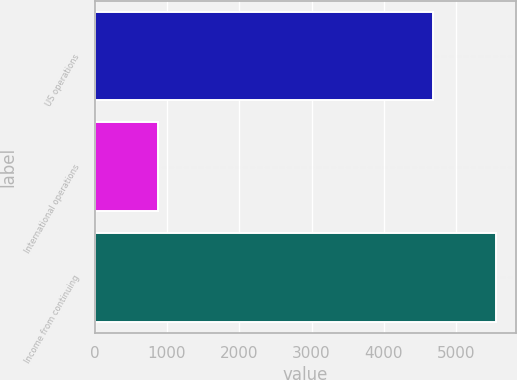Convert chart to OTSL. <chart><loc_0><loc_0><loc_500><loc_500><bar_chart><fcel>US operations<fcel>International operations<fcel>Income from continuing<nl><fcel>4677<fcel>875<fcel>5552<nl></chart> 